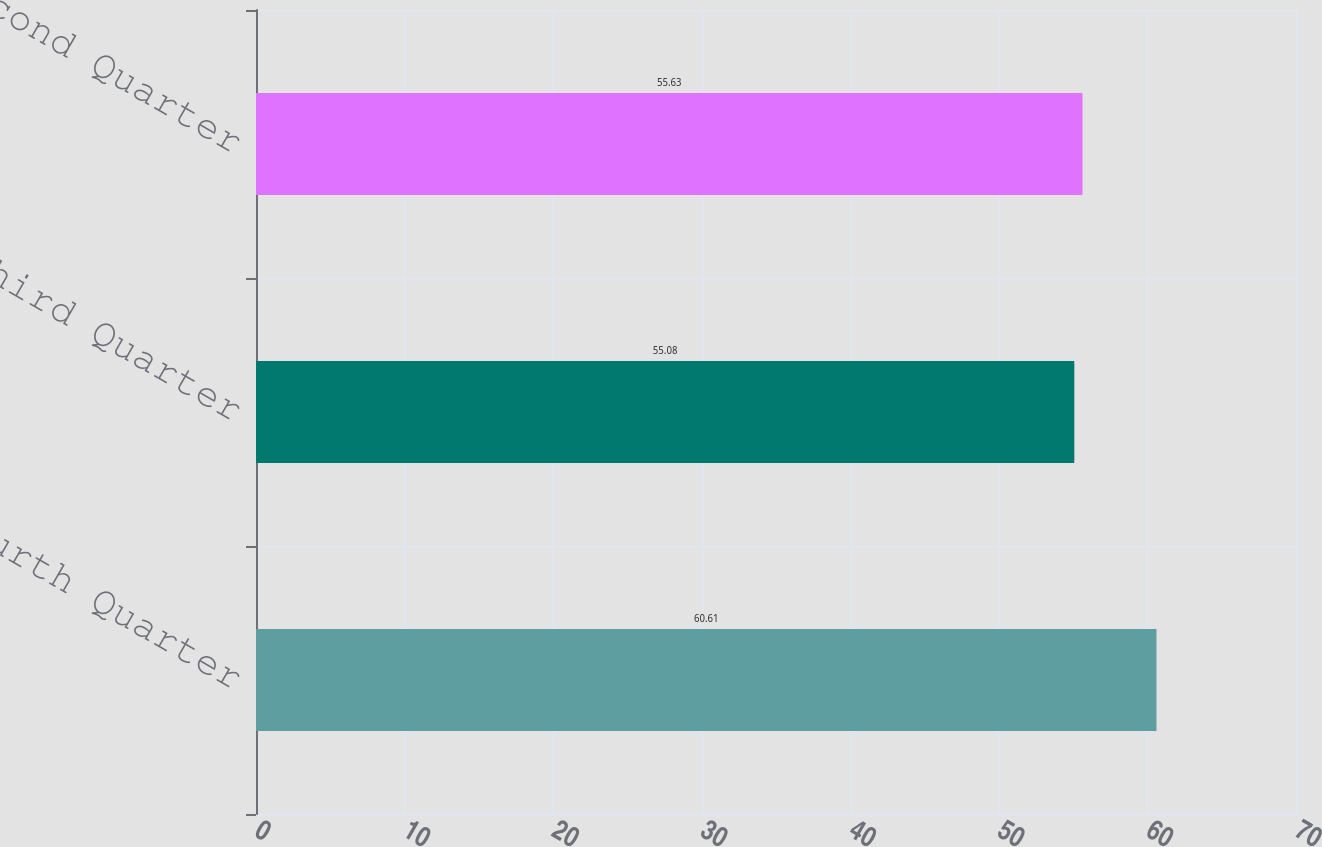<chart> <loc_0><loc_0><loc_500><loc_500><bar_chart><fcel>Fourth Quarter<fcel>Third Quarter<fcel>Second Quarter<nl><fcel>60.61<fcel>55.08<fcel>55.63<nl></chart> 